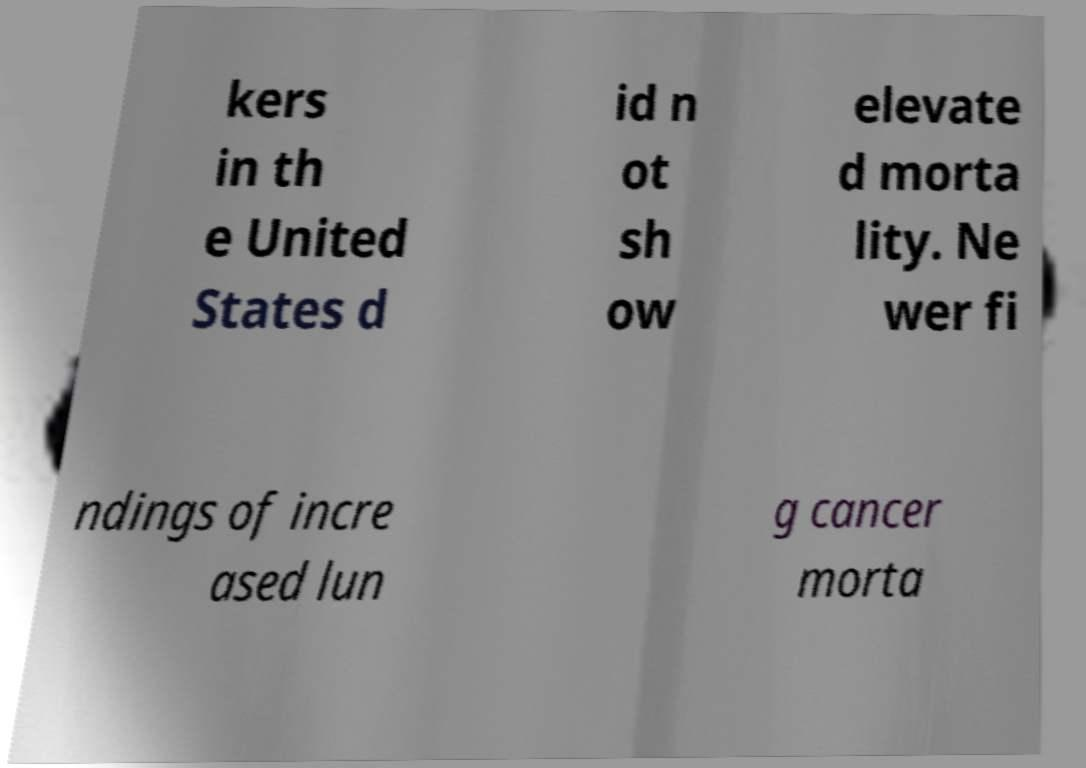Could you assist in decoding the text presented in this image and type it out clearly? kers in th e United States d id n ot sh ow elevate d morta lity. Ne wer fi ndings of incre ased lun g cancer morta 